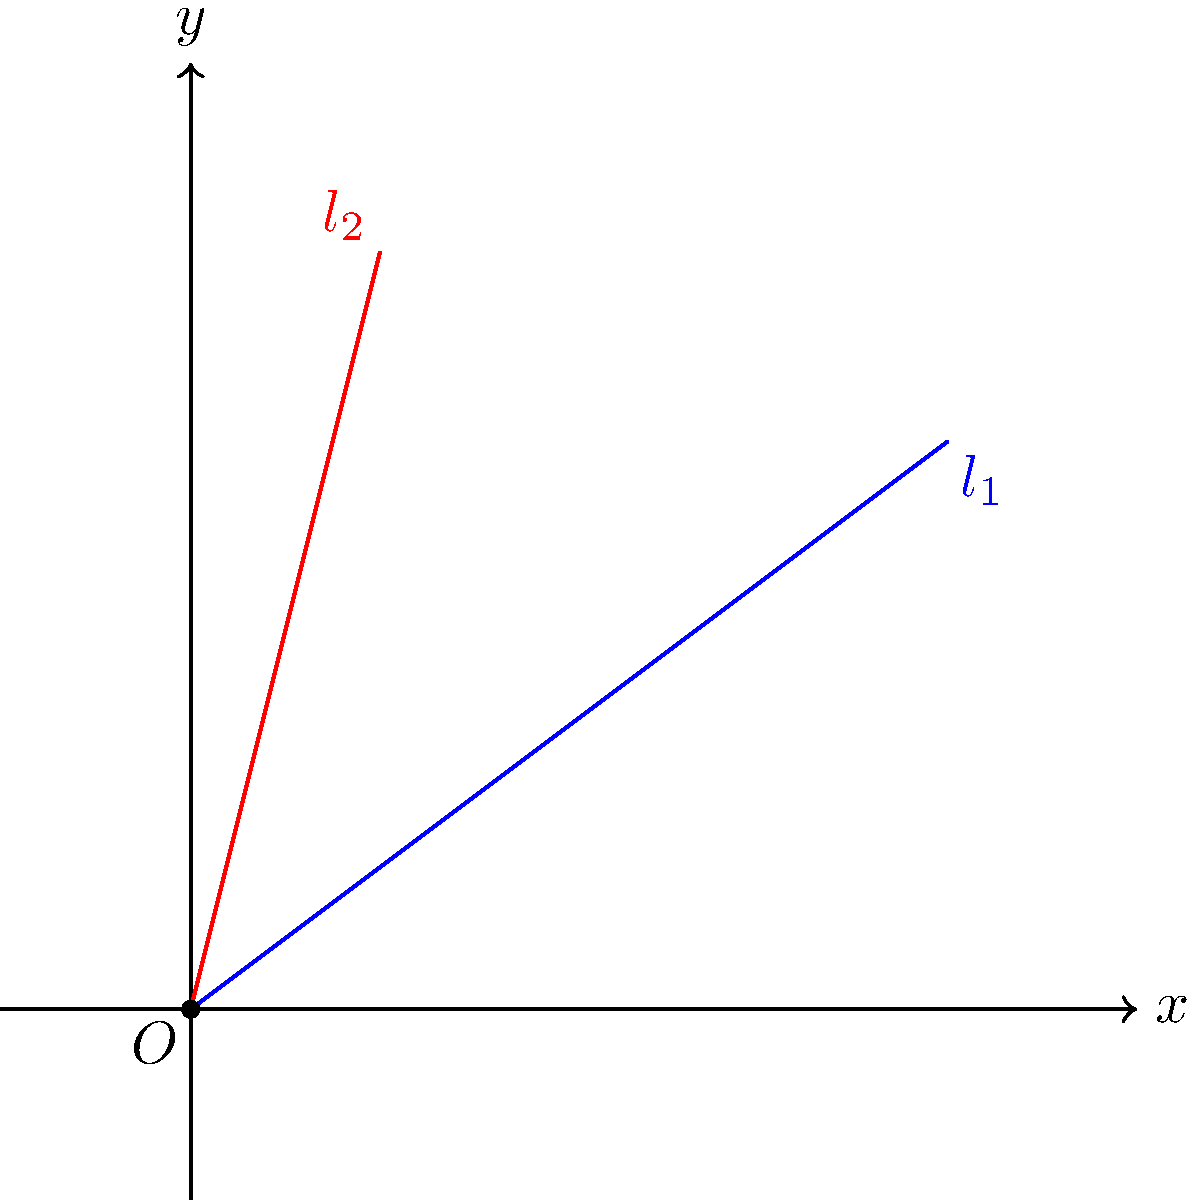In the graph, two lines $l_1$ and $l_2$ intersect at the origin O. Line $l_1$ passes through the point (4, 3), and line $l_2$ passes through the point (1, 4). What is the angle between these two lines in degrees? Round your answer to the nearest whole number.

Hint: In country music, guitars often form angles when played. Imagine these lines as guitar strings! Let's solve this step-by-step:

1) First, we need to find the slopes of both lines.

   For $l_1$: $m_1 = \frac{3}{4}$
   For $l_2$: $m_2 = \frac{4}{1} = 4$

2) The formula for the angle between two lines is:

   $$\tan \theta = \left|\frac{m_2 - m_1}{1 + m_1m_2}\right|$$

3) Let's substitute our values:

   $$\tan \theta = \left|\frac{4 - \frac{3}{4}}{1 + 4 \cdot \frac{3}{4}}\right| = \left|\frac{16 - 3}{4 + 12}\right| = \left|\frac{13}{16}\right|$$

4) Now, we need to find $\theta$:

   $$\theta = \arctan\left(\frac{13}{16}\right)$$

5) Using a calculator or computer:

   $$\theta \approx 39.0945^\circ$$

6) Rounding to the nearest whole number:

   $$\theta \approx 39^\circ$$

This angle is similar to the angle between guitar strings on a country music guitar!
Answer: 39° 